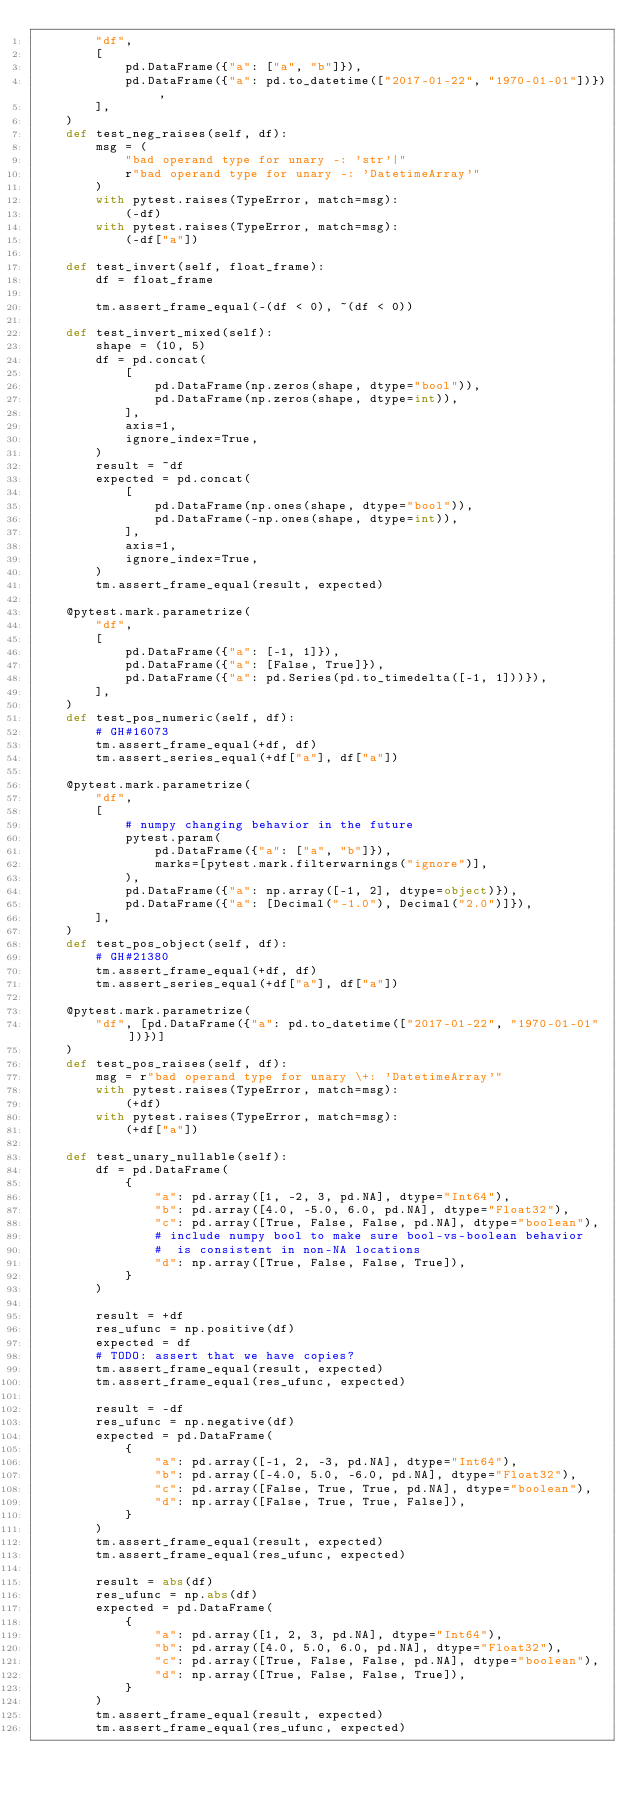<code> <loc_0><loc_0><loc_500><loc_500><_Python_>        "df",
        [
            pd.DataFrame({"a": ["a", "b"]}),
            pd.DataFrame({"a": pd.to_datetime(["2017-01-22", "1970-01-01"])}),
        ],
    )
    def test_neg_raises(self, df):
        msg = (
            "bad operand type for unary -: 'str'|"
            r"bad operand type for unary -: 'DatetimeArray'"
        )
        with pytest.raises(TypeError, match=msg):
            (-df)
        with pytest.raises(TypeError, match=msg):
            (-df["a"])

    def test_invert(self, float_frame):
        df = float_frame

        tm.assert_frame_equal(-(df < 0), ~(df < 0))

    def test_invert_mixed(self):
        shape = (10, 5)
        df = pd.concat(
            [
                pd.DataFrame(np.zeros(shape, dtype="bool")),
                pd.DataFrame(np.zeros(shape, dtype=int)),
            ],
            axis=1,
            ignore_index=True,
        )
        result = ~df
        expected = pd.concat(
            [
                pd.DataFrame(np.ones(shape, dtype="bool")),
                pd.DataFrame(-np.ones(shape, dtype=int)),
            ],
            axis=1,
            ignore_index=True,
        )
        tm.assert_frame_equal(result, expected)

    @pytest.mark.parametrize(
        "df",
        [
            pd.DataFrame({"a": [-1, 1]}),
            pd.DataFrame({"a": [False, True]}),
            pd.DataFrame({"a": pd.Series(pd.to_timedelta([-1, 1]))}),
        ],
    )
    def test_pos_numeric(self, df):
        # GH#16073
        tm.assert_frame_equal(+df, df)
        tm.assert_series_equal(+df["a"], df["a"])

    @pytest.mark.parametrize(
        "df",
        [
            # numpy changing behavior in the future
            pytest.param(
                pd.DataFrame({"a": ["a", "b"]}),
                marks=[pytest.mark.filterwarnings("ignore")],
            ),
            pd.DataFrame({"a": np.array([-1, 2], dtype=object)}),
            pd.DataFrame({"a": [Decimal("-1.0"), Decimal("2.0")]}),
        ],
    )
    def test_pos_object(self, df):
        # GH#21380
        tm.assert_frame_equal(+df, df)
        tm.assert_series_equal(+df["a"], df["a"])

    @pytest.mark.parametrize(
        "df", [pd.DataFrame({"a": pd.to_datetime(["2017-01-22", "1970-01-01"])})]
    )
    def test_pos_raises(self, df):
        msg = r"bad operand type for unary \+: 'DatetimeArray'"
        with pytest.raises(TypeError, match=msg):
            (+df)
        with pytest.raises(TypeError, match=msg):
            (+df["a"])

    def test_unary_nullable(self):
        df = pd.DataFrame(
            {
                "a": pd.array([1, -2, 3, pd.NA], dtype="Int64"),
                "b": pd.array([4.0, -5.0, 6.0, pd.NA], dtype="Float32"),
                "c": pd.array([True, False, False, pd.NA], dtype="boolean"),
                # include numpy bool to make sure bool-vs-boolean behavior
                #  is consistent in non-NA locations
                "d": np.array([True, False, False, True]),
            }
        )

        result = +df
        res_ufunc = np.positive(df)
        expected = df
        # TODO: assert that we have copies?
        tm.assert_frame_equal(result, expected)
        tm.assert_frame_equal(res_ufunc, expected)

        result = -df
        res_ufunc = np.negative(df)
        expected = pd.DataFrame(
            {
                "a": pd.array([-1, 2, -3, pd.NA], dtype="Int64"),
                "b": pd.array([-4.0, 5.0, -6.0, pd.NA], dtype="Float32"),
                "c": pd.array([False, True, True, pd.NA], dtype="boolean"),
                "d": np.array([False, True, True, False]),
            }
        )
        tm.assert_frame_equal(result, expected)
        tm.assert_frame_equal(res_ufunc, expected)

        result = abs(df)
        res_ufunc = np.abs(df)
        expected = pd.DataFrame(
            {
                "a": pd.array([1, 2, 3, pd.NA], dtype="Int64"),
                "b": pd.array([4.0, 5.0, 6.0, pd.NA], dtype="Float32"),
                "c": pd.array([True, False, False, pd.NA], dtype="boolean"),
                "d": np.array([True, False, False, True]),
            }
        )
        tm.assert_frame_equal(result, expected)
        tm.assert_frame_equal(res_ufunc, expected)
</code> 